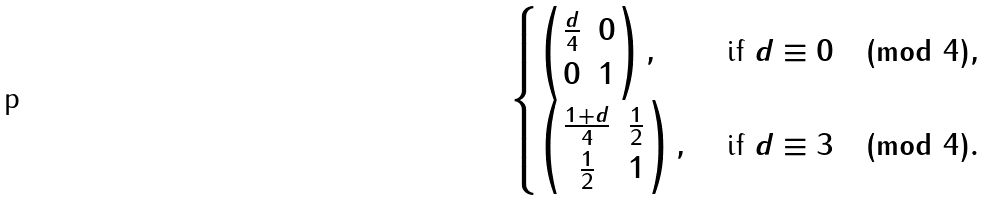<formula> <loc_0><loc_0><loc_500><loc_500>\begin{cases} \begin{pmatrix} \frac { d } { 4 } & 0 \\ 0 & 1 \end{pmatrix} , & \text { if } d \equiv 0 \pmod { 4 } , \\ \begin{pmatrix} \frac { 1 + d } { 4 } & \frac { 1 } { 2 } \\ \frac { 1 } { 2 } & 1 \end{pmatrix} , & \text { if } d \equiv 3 \pmod { 4 } . \end{cases}</formula> 